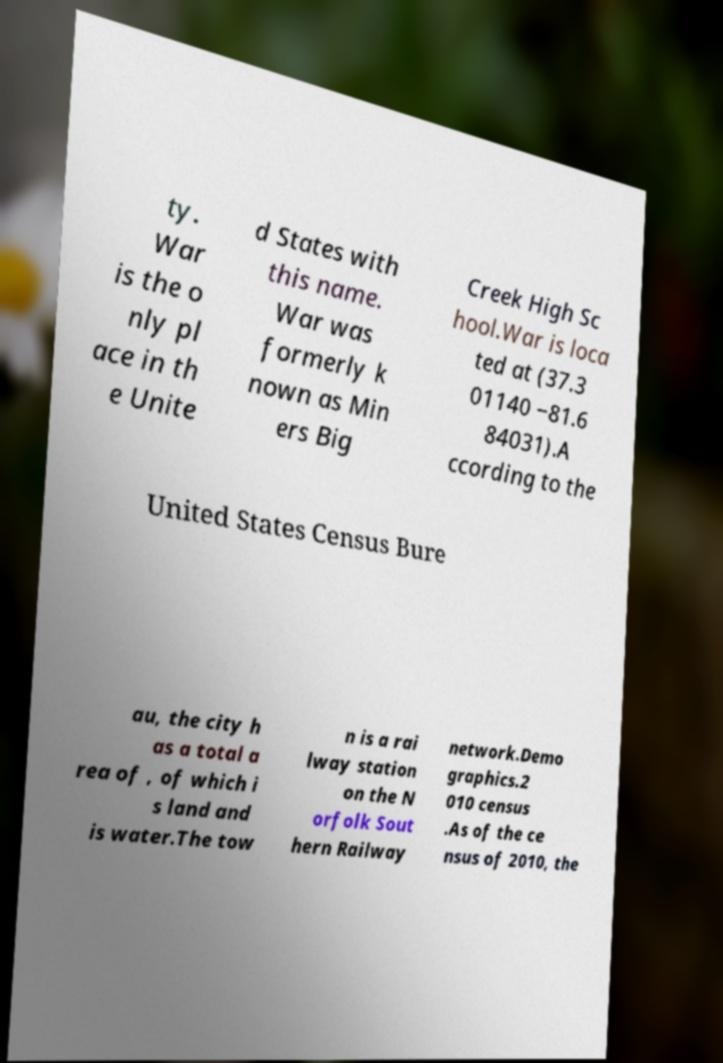Could you assist in decoding the text presented in this image and type it out clearly? ty. War is the o nly pl ace in th e Unite d States with this name. War was formerly k nown as Min ers Big Creek High Sc hool.War is loca ted at (37.3 01140 −81.6 84031).A ccording to the United States Census Bure au, the city h as a total a rea of , of which i s land and is water.The tow n is a rai lway station on the N orfolk Sout hern Railway network.Demo graphics.2 010 census .As of the ce nsus of 2010, the 